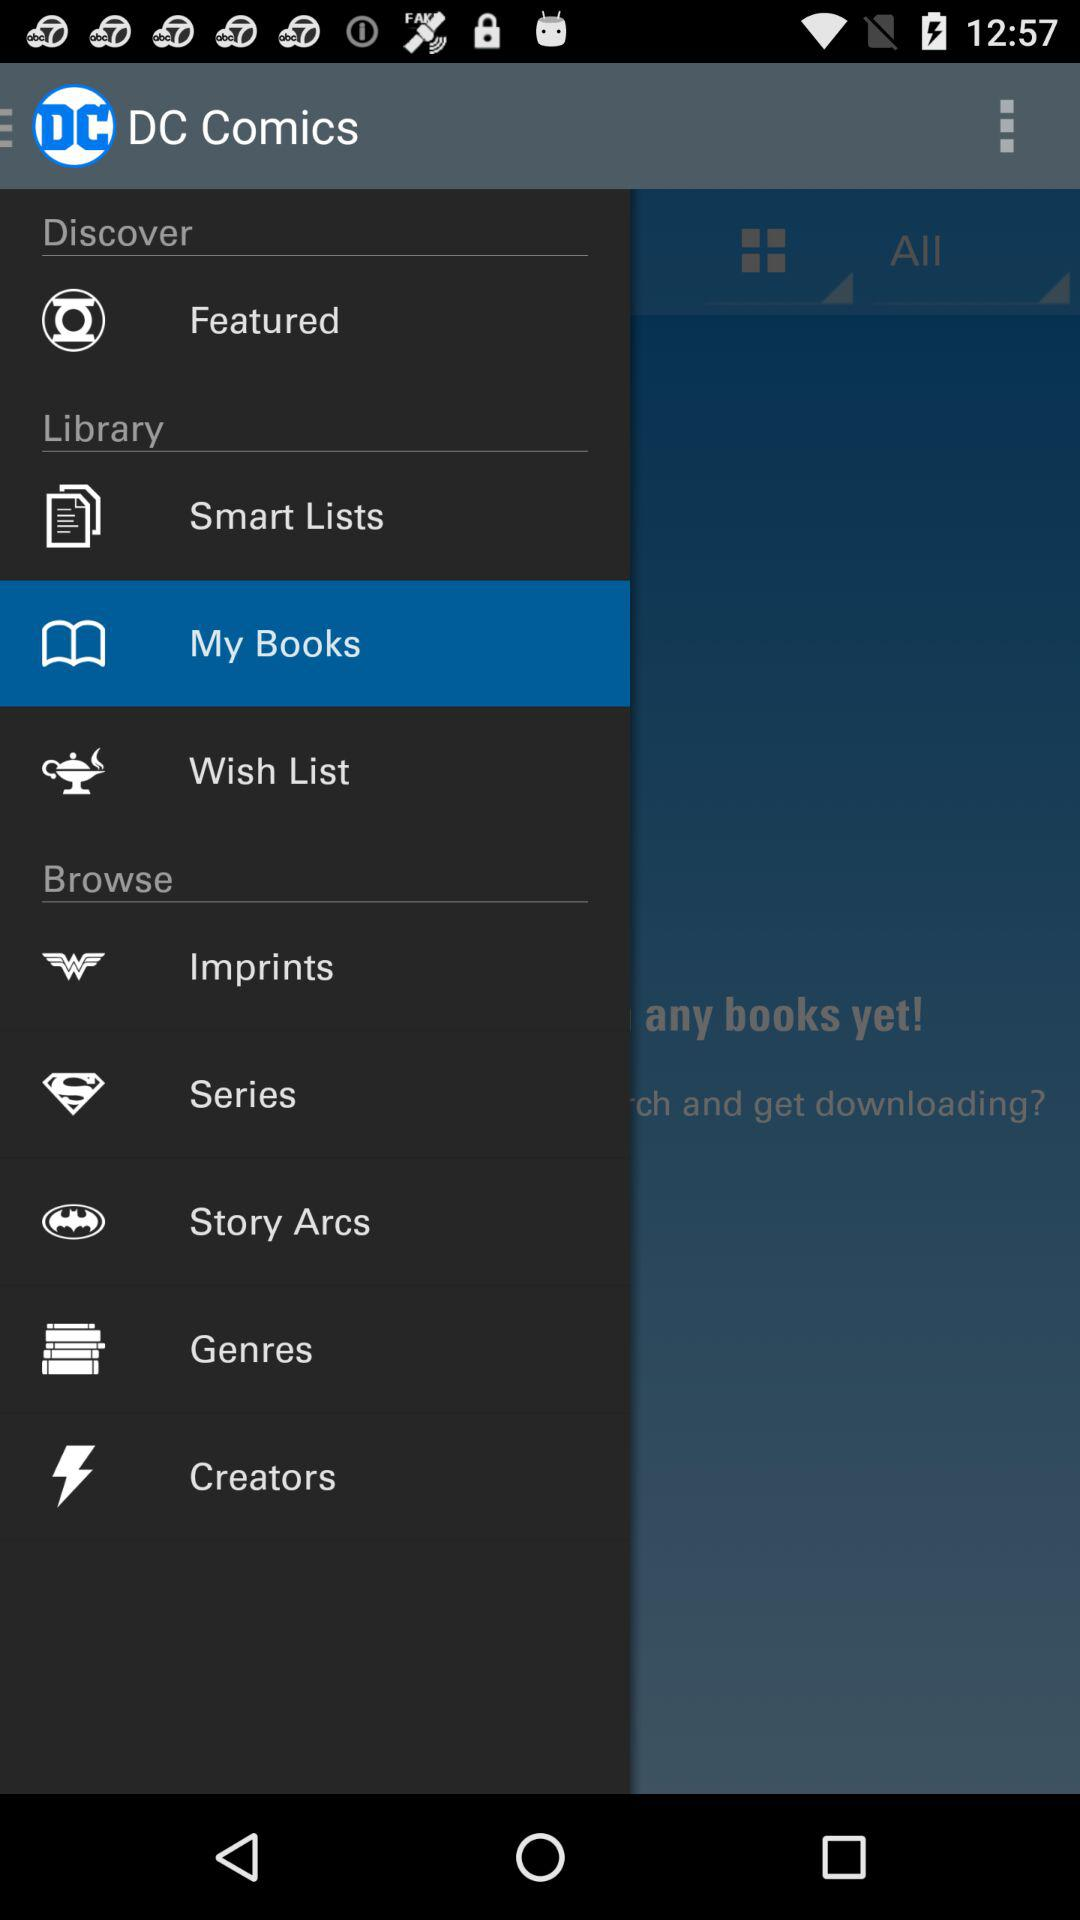What option is selected? The selected option is "My Books". 